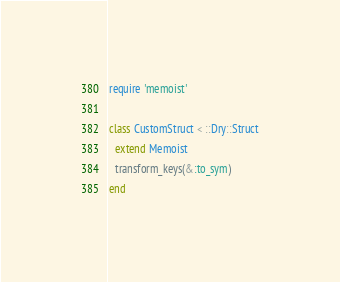Convert code to text. <code><loc_0><loc_0><loc_500><loc_500><_Ruby_>require 'memoist'

class CustomStruct < ::Dry::Struct
  extend Memoist
  transform_keys(&:to_sym)
end
</code> 